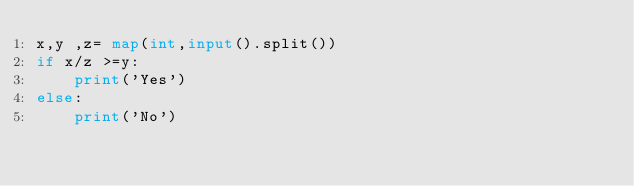<code> <loc_0><loc_0><loc_500><loc_500><_Python_>x,y ,z= map(int,input().split())
if x/z >=y:
	print('Yes')
else:
	print('No')</code> 